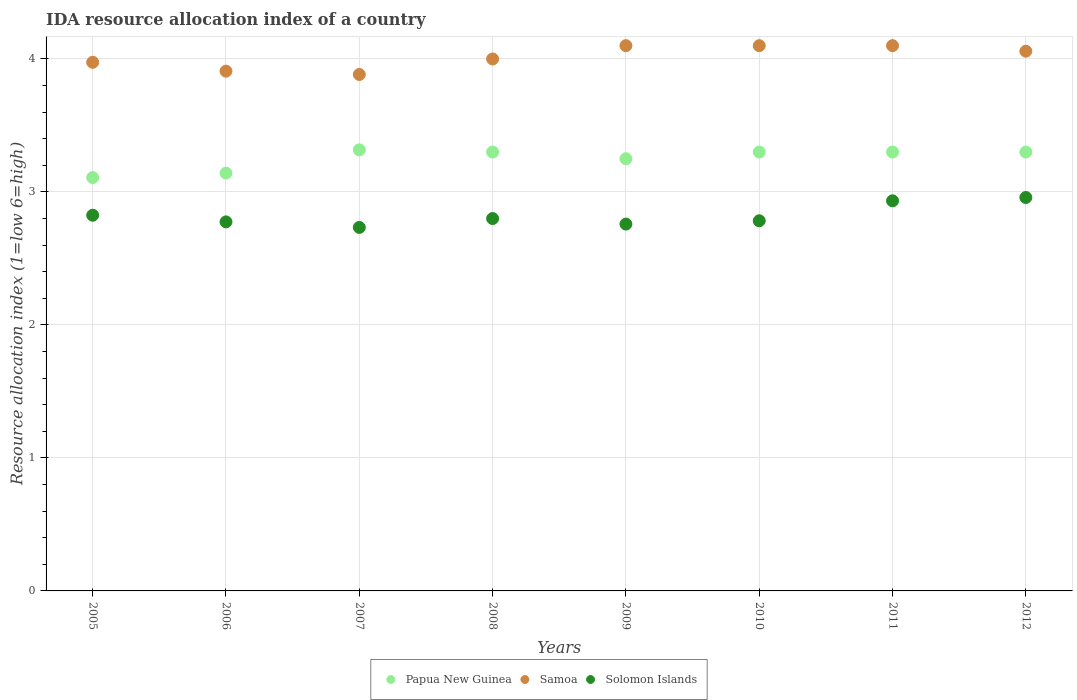How many different coloured dotlines are there?
Your response must be concise. 3. What is the IDA resource allocation index in Samoa in 2012?
Provide a succinct answer. 4.06. Across all years, what is the maximum IDA resource allocation index in Solomon Islands?
Ensure brevity in your answer.  2.96. Across all years, what is the minimum IDA resource allocation index in Samoa?
Keep it short and to the point. 3.88. In which year was the IDA resource allocation index in Papua New Guinea minimum?
Your answer should be very brief. 2005. What is the total IDA resource allocation index in Papua New Guinea in the graph?
Offer a terse response. 26.02. What is the difference between the IDA resource allocation index in Papua New Guinea in 2010 and that in 2012?
Offer a terse response. 0. What is the difference between the IDA resource allocation index in Samoa in 2010 and the IDA resource allocation index in Solomon Islands in 2009?
Make the answer very short. 1.34. What is the average IDA resource allocation index in Samoa per year?
Keep it short and to the point. 4.02. In the year 2008, what is the difference between the IDA resource allocation index in Papua New Guinea and IDA resource allocation index in Solomon Islands?
Offer a very short reply. 0.5. In how many years, is the IDA resource allocation index in Solomon Islands greater than 0.8?
Offer a very short reply. 8. What is the ratio of the IDA resource allocation index in Papua New Guinea in 2007 to that in 2010?
Your response must be concise. 1.01. Is the IDA resource allocation index in Papua New Guinea in 2006 less than that in 2011?
Make the answer very short. Yes. Is the difference between the IDA resource allocation index in Papua New Guinea in 2008 and 2011 greater than the difference between the IDA resource allocation index in Solomon Islands in 2008 and 2011?
Provide a short and direct response. Yes. What is the difference between the highest and the second highest IDA resource allocation index in Papua New Guinea?
Your answer should be compact. 0.02. What is the difference between the highest and the lowest IDA resource allocation index in Samoa?
Your answer should be very brief. 0.22. In how many years, is the IDA resource allocation index in Samoa greater than the average IDA resource allocation index in Samoa taken over all years?
Give a very brief answer. 4. How many dotlines are there?
Your answer should be compact. 3. What is the difference between two consecutive major ticks on the Y-axis?
Provide a short and direct response. 1. Are the values on the major ticks of Y-axis written in scientific E-notation?
Provide a short and direct response. No. Does the graph contain grids?
Make the answer very short. Yes. Where does the legend appear in the graph?
Keep it short and to the point. Bottom center. How are the legend labels stacked?
Provide a succinct answer. Horizontal. What is the title of the graph?
Provide a succinct answer. IDA resource allocation index of a country. Does "Greenland" appear as one of the legend labels in the graph?
Ensure brevity in your answer.  No. What is the label or title of the Y-axis?
Give a very brief answer. Resource allocation index (1=low 6=high). What is the Resource allocation index (1=low 6=high) in Papua New Guinea in 2005?
Your answer should be very brief. 3.11. What is the Resource allocation index (1=low 6=high) of Samoa in 2005?
Provide a short and direct response. 3.98. What is the Resource allocation index (1=low 6=high) in Solomon Islands in 2005?
Keep it short and to the point. 2.83. What is the Resource allocation index (1=low 6=high) of Papua New Guinea in 2006?
Make the answer very short. 3.14. What is the Resource allocation index (1=low 6=high) in Samoa in 2006?
Give a very brief answer. 3.91. What is the Resource allocation index (1=low 6=high) in Solomon Islands in 2006?
Keep it short and to the point. 2.77. What is the Resource allocation index (1=low 6=high) in Papua New Guinea in 2007?
Offer a terse response. 3.32. What is the Resource allocation index (1=low 6=high) of Samoa in 2007?
Keep it short and to the point. 3.88. What is the Resource allocation index (1=low 6=high) of Solomon Islands in 2007?
Keep it short and to the point. 2.73. What is the Resource allocation index (1=low 6=high) in Samoa in 2008?
Offer a terse response. 4. What is the Resource allocation index (1=low 6=high) in Solomon Islands in 2008?
Offer a terse response. 2.8. What is the Resource allocation index (1=low 6=high) of Papua New Guinea in 2009?
Your answer should be very brief. 3.25. What is the Resource allocation index (1=low 6=high) in Solomon Islands in 2009?
Offer a terse response. 2.76. What is the Resource allocation index (1=low 6=high) of Papua New Guinea in 2010?
Give a very brief answer. 3.3. What is the Resource allocation index (1=low 6=high) of Samoa in 2010?
Your response must be concise. 4.1. What is the Resource allocation index (1=low 6=high) of Solomon Islands in 2010?
Offer a very short reply. 2.78. What is the Resource allocation index (1=low 6=high) of Papua New Guinea in 2011?
Make the answer very short. 3.3. What is the Resource allocation index (1=low 6=high) of Solomon Islands in 2011?
Give a very brief answer. 2.93. What is the Resource allocation index (1=low 6=high) of Papua New Guinea in 2012?
Your answer should be very brief. 3.3. What is the Resource allocation index (1=low 6=high) in Samoa in 2012?
Give a very brief answer. 4.06. What is the Resource allocation index (1=low 6=high) of Solomon Islands in 2012?
Your response must be concise. 2.96. Across all years, what is the maximum Resource allocation index (1=low 6=high) in Papua New Guinea?
Your response must be concise. 3.32. Across all years, what is the maximum Resource allocation index (1=low 6=high) in Solomon Islands?
Your answer should be very brief. 2.96. Across all years, what is the minimum Resource allocation index (1=low 6=high) in Papua New Guinea?
Your answer should be very brief. 3.11. Across all years, what is the minimum Resource allocation index (1=low 6=high) of Samoa?
Provide a succinct answer. 3.88. Across all years, what is the minimum Resource allocation index (1=low 6=high) in Solomon Islands?
Ensure brevity in your answer.  2.73. What is the total Resource allocation index (1=low 6=high) in Papua New Guinea in the graph?
Provide a succinct answer. 26.02. What is the total Resource allocation index (1=low 6=high) in Samoa in the graph?
Give a very brief answer. 32.12. What is the total Resource allocation index (1=low 6=high) in Solomon Islands in the graph?
Offer a very short reply. 22.57. What is the difference between the Resource allocation index (1=low 6=high) of Papua New Guinea in 2005 and that in 2006?
Your response must be concise. -0.03. What is the difference between the Resource allocation index (1=low 6=high) of Samoa in 2005 and that in 2006?
Keep it short and to the point. 0.07. What is the difference between the Resource allocation index (1=low 6=high) in Papua New Guinea in 2005 and that in 2007?
Offer a very short reply. -0.21. What is the difference between the Resource allocation index (1=low 6=high) in Samoa in 2005 and that in 2007?
Provide a succinct answer. 0.09. What is the difference between the Resource allocation index (1=low 6=high) of Solomon Islands in 2005 and that in 2007?
Your answer should be compact. 0.09. What is the difference between the Resource allocation index (1=low 6=high) of Papua New Guinea in 2005 and that in 2008?
Offer a terse response. -0.19. What is the difference between the Resource allocation index (1=low 6=high) in Samoa in 2005 and that in 2008?
Your response must be concise. -0.03. What is the difference between the Resource allocation index (1=low 6=high) of Solomon Islands in 2005 and that in 2008?
Offer a terse response. 0.03. What is the difference between the Resource allocation index (1=low 6=high) of Papua New Guinea in 2005 and that in 2009?
Ensure brevity in your answer.  -0.14. What is the difference between the Resource allocation index (1=low 6=high) of Samoa in 2005 and that in 2009?
Your answer should be very brief. -0.12. What is the difference between the Resource allocation index (1=low 6=high) of Solomon Islands in 2005 and that in 2009?
Make the answer very short. 0.07. What is the difference between the Resource allocation index (1=low 6=high) of Papua New Guinea in 2005 and that in 2010?
Give a very brief answer. -0.19. What is the difference between the Resource allocation index (1=low 6=high) in Samoa in 2005 and that in 2010?
Your response must be concise. -0.12. What is the difference between the Resource allocation index (1=low 6=high) in Solomon Islands in 2005 and that in 2010?
Provide a succinct answer. 0.04. What is the difference between the Resource allocation index (1=low 6=high) in Papua New Guinea in 2005 and that in 2011?
Your response must be concise. -0.19. What is the difference between the Resource allocation index (1=low 6=high) of Samoa in 2005 and that in 2011?
Keep it short and to the point. -0.12. What is the difference between the Resource allocation index (1=low 6=high) of Solomon Islands in 2005 and that in 2011?
Offer a very short reply. -0.11. What is the difference between the Resource allocation index (1=low 6=high) of Papua New Guinea in 2005 and that in 2012?
Provide a short and direct response. -0.19. What is the difference between the Resource allocation index (1=low 6=high) of Samoa in 2005 and that in 2012?
Provide a short and direct response. -0.08. What is the difference between the Resource allocation index (1=low 6=high) of Solomon Islands in 2005 and that in 2012?
Provide a short and direct response. -0.13. What is the difference between the Resource allocation index (1=low 6=high) in Papua New Guinea in 2006 and that in 2007?
Give a very brief answer. -0.17. What is the difference between the Resource allocation index (1=low 6=high) of Samoa in 2006 and that in 2007?
Provide a succinct answer. 0.03. What is the difference between the Resource allocation index (1=low 6=high) in Solomon Islands in 2006 and that in 2007?
Your answer should be very brief. 0.04. What is the difference between the Resource allocation index (1=low 6=high) of Papua New Guinea in 2006 and that in 2008?
Ensure brevity in your answer.  -0.16. What is the difference between the Resource allocation index (1=low 6=high) of Samoa in 2006 and that in 2008?
Your response must be concise. -0.09. What is the difference between the Resource allocation index (1=low 6=high) in Solomon Islands in 2006 and that in 2008?
Provide a short and direct response. -0.03. What is the difference between the Resource allocation index (1=low 6=high) in Papua New Guinea in 2006 and that in 2009?
Offer a very short reply. -0.11. What is the difference between the Resource allocation index (1=low 6=high) of Samoa in 2006 and that in 2009?
Give a very brief answer. -0.19. What is the difference between the Resource allocation index (1=low 6=high) of Solomon Islands in 2006 and that in 2009?
Ensure brevity in your answer.  0.02. What is the difference between the Resource allocation index (1=low 6=high) in Papua New Guinea in 2006 and that in 2010?
Offer a very short reply. -0.16. What is the difference between the Resource allocation index (1=low 6=high) of Samoa in 2006 and that in 2010?
Offer a very short reply. -0.19. What is the difference between the Resource allocation index (1=low 6=high) of Solomon Islands in 2006 and that in 2010?
Your answer should be compact. -0.01. What is the difference between the Resource allocation index (1=low 6=high) of Papua New Guinea in 2006 and that in 2011?
Provide a succinct answer. -0.16. What is the difference between the Resource allocation index (1=low 6=high) in Samoa in 2006 and that in 2011?
Offer a terse response. -0.19. What is the difference between the Resource allocation index (1=low 6=high) in Solomon Islands in 2006 and that in 2011?
Your answer should be compact. -0.16. What is the difference between the Resource allocation index (1=low 6=high) in Papua New Guinea in 2006 and that in 2012?
Give a very brief answer. -0.16. What is the difference between the Resource allocation index (1=low 6=high) in Samoa in 2006 and that in 2012?
Ensure brevity in your answer.  -0.15. What is the difference between the Resource allocation index (1=low 6=high) in Solomon Islands in 2006 and that in 2012?
Keep it short and to the point. -0.18. What is the difference between the Resource allocation index (1=low 6=high) in Papua New Guinea in 2007 and that in 2008?
Make the answer very short. 0.02. What is the difference between the Resource allocation index (1=low 6=high) in Samoa in 2007 and that in 2008?
Your response must be concise. -0.12. What is the difference between the Resource allocation index (1=low 6=high) in Solomon Islands in 2007 and that in 2008?
Make the answer very short. -0.07. What is the difference between the Resource allocation index (1=low 6=high) of Papua New Guinea in 2007 and that in 2009?
Your answer should be very brief. 0.07. What is the difference between the Resource allocation index (1=low 6=high) of Samoa in 2007 and that in 2009?
Offer a very short reply. -0.22. What is the difference between the Resource allocation index (1=low 6=high) in Solomon Islands in 2007 and that in 2009?
Offer a very short reply. -0.03. What is the difference between the Resource allocation index (1=low 6=high) of Papua New Guinea in 2007 and that in 2010?
Your response must be concise. 0.02. What is the difference between the Resource allocation index (1=low 6=high) in Samoa in 2007 and that in 2010?
Provide a short and direct response. -0.22. What is the difference between the Resource allocation index (1=low 6=high) of Solomon Islands in 2007 and that in 2010?
Your answer should be very brief. -0.05. What is the difference between the Resource allocation index (1=low 6=high) in Papua New Guinea in 2007 and that in 2011?
Offer a terse response. 0.02. What is the difference between the Resource allocation index (1=low 6=high) in Samoa in 2007 and that in 2011?
Give a very brief answer. -0.22. What is the difference between the Resource allocation index (1=low 6=high) of Papua New Guinea in 2007 and that in 2012?
Give a very brief answer. 0.02. What is the difference between the Resource allocation index (1=low 6=high) in Samoa in 2007 and that in 2012?
Keep it short and to the point. -0.17. What is the difference between the Resource allocation index (1=low 6=high) of Solomon Islands in 2007 and that in 2012?
Keep it short and to the point. -0.23. What is the difference between the Resource allocation index (1=low 6=high) in Solomon Islands in 2008 and that in 2009?
Your response must be concise. 0.04. What is the difference between the Resource allocation index (1=low 6=high) of Samoa in 2008 and that in 2010?
Your answer should be compact. -0.1. What is the difference between the Resource allocation index (1=low 6=high) in Solomon Islands in 2008 and that in 2010?
Offer a terse response. 0.02. What is the difference between the Resource allocation index (1=low 6=high) in Papua New Guinea in 2008 and that in 2011?
Provide a short and direct response. 0. What is the difference between the Resource allocation index (1=low 6=high) of Solomon Islands in 2008 and that in 2011?
Give a very brief answer. -0.13. What is the difference between the Resource allocation index (1=low 6=high) in Papua New Guinea in 2008 and that in 2012?
Make the answer very short. 0. What is the difference between the Resource allocation index (1=low 6=high) in Samoa in 2008 and that in 2012?
Provide a short and direct response. -0.06. What is the difference between the Resource allocation index (1=low 6=high) of Solomon Islands in 2008 and that in 2012?
Provide a succinct answer. -0.16. What is the difference between the Resource allocation index (1=low 6=high) of Papua New Guinea in 2009 and that in 2010?
Provide a succinct answer. -0.05. What is the difference between the Resource allocation index (1=low 6=high) of Samoa in 2009 and that in 2010?
Keep it short and to the point. 0. What is the difference between the Resource allocation index (1=low 6=high) of Solomon Islands in 2009 and that in 2010?
Your answer should be compact. -0.03. What is the difference between the Resource allocation index (1=low 6=high) in Papua New Guinea in 2009 and that in 2011?
Keep it short and to the point. -0.05. What is the difference between the Resource allocation index (1=low 6=high) in Samoa in 2009 and that in 2011?
Keep it short and to the point. 0. What is the difference between the Resource allocation index (1=low 6=high) in Solomon Islands in 2009 and that in 2011?
Your answer should be compact. -0.17. What is the difference between the Resource allocation index (1=low 6=high) of Samoa in 2009 and that in 2012?
Provide a succinct answer. 0.04. What is the difference between the Resource allocation index (1=low 6=high) of Papua New Guinea in 2010 and that in 2011?
Your answer should be compact. 0. What is the difference between the Resource allocation index (1=low 6=high) of Samoa in 2010 and that in 2011?
Your response must be concise. 0. What is the difference between the Resource allocation index (1=low 6=high) in Samoa in 2010 and that in 2012?
Give a very brief answer. 0.04. What is the difference between the Resource allocation index (1=low 6=high) of Solomon Islands in 2010 and that in 2012?
Ensure brevity in your answer.  -0.17. What is the difference between the Resource allocation index (1=low 6=high) of Samoa in 2011 and that in 2012?
Your response must be concise. 0.04. What is the difference between the Resource allocation index (1=low 6=high) of Solomon Islands in 2011 and that in 2012?
Your answer should be compact. -0.03. What is the difference between the Resource allocation index (1=low 6=high) in Papua New Guinea in 2005 and the Resource allocation index (1=low 6=high) in Samoa in 2007?
Your answer should be compact. -0.78. What is the difference between the Resource allocation index (1=low 6=high) of Papua New Guinea in 2005 and the Resource allocation index (1=low 6=high) of Solomon Islands in 2007?
Offer a very short reply. 0.38. What is the difference between the Resource allocation index (1=low 6=high) of Samoa in 2005 and the Resource allocation index (1=low 6=high) of Solomon Islands in 2007?
Keep it short and to the point. 1.24. What is the difference between the Resource allocation index (1=low 6=high) of Papua New Guinea in 2005 and the Resource allocation index (1=low 6=high) of Samoa in 2008?
Your response must be concise. -0.89. What is the difference between the Resource allocation index (1=low 6=high) of Papua New Guinea in 2005 and the Resource allocation index (1=low 6=high) of Solomon Islands in 2008?
Provide a succinct answer. 0.31. What is the difference between the Resource allocation index (1=low 6=high) of Samoa in 2005 and the Resource allocation index (1=low 6=high) of Solomon Islands in 2008?
Give a very brief answer. 1.18. What is the difference between the Resource allocation index (1=low 6=high) of Papua New Guinea in 2005 and the Resource allocation index (1=low 6=high) of Samoa in 2009?
Make the answer very short. -0.99. What is the difference between the Resource allocation index (1=low 6=high) in Papua New Guinea in 2005 and the Resource allocation index (1=low 6=high) in Solomon Islands in 2009?
Keep it short and to the point. 0.35. What is the difference between the Resource allocation index (1=low 6=high) of Samoa in 2005 and the Resource allocation index (1=low 6=high) of Solomon Islands in 2009?
Keep it short and to the point. 1.22. What is the difference between the Resource allocation index (1=low 6=high) of Papua New Guinea in 2005 and the Resource allocation index (1=low 6=high) of Samoa in 2010?
Make the answer very short. -0.99. What is the difference between the Resource allocation index (1=low 6=high) of Papua New Guinea in 2005 and the Resource allocation index (1=low 6=high) of Solomon Islands in 2010?
Provide a succinct answer. 0.33. What is the difference between the Resource allocation index (1=low 6=high) in Samoa in 2005 and the Resource allocation index (1=low 6=high) in Solomon Islands in 2010?
Offer a very short reply. 1.19. What is the difference between the Resource allocation index (1=low 6=high) of Papua New Guinea in 2005 and the Resource allocation index (1=low 6=high) of Samoa in 2011?
Make the answer very short. -0.99. What is the difference between the Resource allocation index (1=low 6=high) of Papua New Guinea in 2005 and the Resource allocation index (1=low 6=high) of Solomon Islands in 2011?
Offer a terse response. 0.17. What is the difference between the Resource allocation index (1=low 6=high) in Samoa in 2005 and the Resource allocation index (1=low 6=high) in Solomon Islands in 2011?
Give a very brief answer. 1.04. What is the difference between the Resource allocation index (1=low 6=high) in Papua New Guinea in 2005 and the Resource allocation index (1=low 6=high) in Samoa in 2012?
Your response must be concise. -0.95. What is the difference between the Resource allocation index (1=low 6=high) in Samoa in 2005 and the Resource allocation index (1=low 6=high) in Solomon Islands in 2012?
Give a very brief answer. 1.02. What is the difference between the Resource allocation index (1=low 6=high) in Papua New Guinea in 2006 and the Resource allocation index (1=low 6=high) in Samoa in 2007?
Offer a terse response. -0.74. What is the difference between the Resource allocation index (1=low 6=high) of Papua New Guinea in 2006 and the Resource allocation index (1=low 6=high) of Solomon Islands in 2007?
Offer a terse response. 0.41. What is the difference between the Resource allocation index (1=low 6=high) of Samoa in 2006 and the Resource allocation index (1=low 6=high) of Solomon Islands in 2007?
Your answer should be very brief. 1.18. What is the difference between the Resource allocation index (1=low 6=high) in Papua New Guinea in 2006 and the Resource allocation index (1=low 6=high) in Samoa in 2008?
Make the answer very short. -0.86. What is the difference between the Resource allocation index (1=low 6=high) in Papua New Guinea in 2006 and the Resource allocation index (1=low 6=high) in Solomon Islands in 2008?
Your response must be concise. 0.34. What is the difference between the Resource allocation index (1=low 6=high) in Samoa in 2006 and the Resource allocation index (1=low 6=high) in Solomon Islands in 2008?
Your answer should be very brief. 1.11. What is the difference between the Resource allocation index (1=low 6=high) of Papua New Guinea in 2006 and the Resource allocation index (1=low 6=high) of Samoa in 2009?
Ensure brevity in your answer.  -0.96. What is the difference between the Resource allocation index (1=low 6=high) of Papua New Guinea in 2006 and the Resource allocation index (1=low 6=high) of Solomon Islands in 2009?
Give a very brief answer. 0.38. What is the difference between the Resource allocation index (1=low 6=high) in Samoa in 2006 and the Resource allocation index (1=low 6=high) in Solomon Islands in 2009?
Ensure brevity in your answer.  1.15. What is the difference between the Resource allocation index (1=low 6=high) of Papua New Guinea in 2006 and the Resource allocation index (1=low 6=high) of Samoa in 2010?
Your answer should be compact. -0.96. What is the difference between the Resource allocation index (1=low 6=high) in Papua New Guinea in 2006 and the Resource allocation index (1=low 6=high) in Solomon Islands in 2010?
Ensure brevity in your answer.  0.36. What is the difference between the Resource allocation index (1=low 6=high) in Samoa in 2006 and the Resource allocation index (1=low 6=high) in Solomon Islands in 2010?
Your answer should be very brief. 1.12. What is the difference between the Resource allocation index (1=low 6=high) in Papua New Guinea in 2006 and the Resource allocation index (1=low 6=high) in Samoa in 2011?
Make the answer very short. -0.96. What is the difference between the Resource allocation index (1=low 6=high) in Papua New Guinea in 2006 and the Resource allocation index (1=low 6=high) in Solomon Islands in 2011?
Offer a terse response. 0.21. What is the difference between the Resource allocation index (1=low 6=high) of Papua New Guinea in 2006 and the Resource allocation index (1=low 6=high) of Samoa in 2012?
Your response must be concise. -0.92. What is the difference between the Resource allocation index (1=low 6=high) in Papua New Guinea in 2006 and the Resource allocation index (1=low 6=high) in Solomon Islands in 2012?
Make the answer very short. 0.18. What is the difference between the Resource allocation index (1=low 6=high) in Papua New Guinea in 2007 and the Resource allocation index (1=low 6=high) in Samoa in 2008?
Offer a very short reply. -0.68. What is the difference between the Resource allocation index (1=low 6=high) in Papua New Guinea in 2007 and the Resource allocation index (1=low 6=high) in Solomon Islands in 2008?
Provide a short and direct response. 0.52. What is the difference between the Resource allocation index (1=low 6=high) of Papua New Guinea in 2007 and the Resource allocation index (1=low 6=high) of Samoa in 2009?
Offer a terse response. -0.78. What is the difference between the Resource allocation index (1=low 6=high) of Papua New Guinea in 2007 and the Resource allocation index (1=low 6=high) of Solomon Islands in 2009?
Provide a short and direct response. 0.56. What is the difference between the Resource allocation index (1=low 6=high) in Samoa in 2007 and the Resource allocation index (1=low 6=high) in Solomon Islands in 2009?
Your answer should be compact. 1.12. What is the difference between the Resource allocation index (1=low 6=high) of Papua New Guinea in 2007 and the Resource allocation index (1=low 6=high) of Samoa in 2010?
Make the answer very short. -0.78. What is the difference between the Resource allocation index (1=low 6=high) of Papua New Guinea in 2007 and the Resource allocation index (1=low 6=high) of Solomon Islands in 2010?
Provide a succinct answer. 0.53. What is the difference between the Resource allocation index (1=low 6=high) in Papua New Guinea in 2007 and the Resource allocation index (1=low 6=high) in Samoa in 2011?
Provide a short and direct response. -0.78. What is the difference between the Resource allocation index (1=low 6=high) in Papua New Guinea in 2007 and the Resource allocation index (1=low 6=high) in Solomon Islands in 2011?
Ensure brevity in your answer.  0.38. What is the difference between the Resource allocation index (1=low 6=high) of Papua New Guinea in 2007 and the Resource allocation index (1=low 6=high) of Samoa in 2012?
Your answer should be very brief. -0.74. What is the difference between the Resource allocation index (1=low 6=high) of Papua New Guinea in 2007 and the Resource allocation index (1=low 6=high) of Solomon Islands in 2012?
Make the answer very short. 0.36. What is the difference between the Resource allocation index (1=low 6=high) of Samoa in 2007 and the Resource allocation index (1=low 6=high) of Solomon Islands in 2012?
Your answer should be compact. 0.93. What is the difference between the Resource allocation index (1=low 6=high) in Papua New Guinea in 2008 and the Resource allocation index (1=low 6=high) in Solomon Islands in 2009?
Provide a succinct answer. 0.54. What is the difference between the Resource allocation index (1=low 6=high) in Samoa in 2008 and the Resource allocation index (1=low 6=high) in Solomon Islands in 2009?
Your answer should be compact. 1.24. What is the difference between the Resource allocation index (1=low 6=high) of Papua New Guinea in 2008 and the Resource allocation index (1=low 6=high) of Solomon Islands in 2010?
Offer a very short reply. 0.52. What is the difference between the Resource allocation index (1=low 6=high) of Samoa in 2008 and the Resource allocation index (1=low 6=high) of Solomon Islands in 2010?
Ensure brevity in your answer.  1.22. What is the difference between the Resource allocation index (1=low 6=high) of Papua New Guinea in 2008 and the Resource allocation index (1=low 6=high) of Samoa in 2011?
Provide a succinct answer. -0.8. What is the difference between the Resource allocation index (1=low 6=high) of Papua New Guinea in 2008 and the Resource allocation index (1=low 6=high) of Solomon Islands in 2011?
Give a very brief answer. 0.37. What is the difference between the Resource allocation index (1=low 6=high) of Samoa in 2008 and the Resource allocation index (1=low 6=high) of Solomon Islands in 2011?
Keep it short and to the point. 1.07. What is the difference between the Resource allocation index (1=low 6=high) of Papua New Guinea in 2008 and the Resource allocation index (1=low 6=high) of Samoa in 2012?
Ensure brevity in your answer.  -0.76. What is the difference between the Resource allocation index (1=low 6=high) of Papua New Guinea in 2008 and the Resource allocation index (1=low 6=high) of Solomon Islands in 2012?
Give a very brief answer. 0.34. What is the difference between the Resource allocation index (1=low 6=high) of Samoa in 2008 and the Resource allocation index (1=low 6=high) of Solomon Islands in 2012?
Offer a very short reply. 1.04. What is the difference between the Resource allocation index (1=low 6=high) of Papua New Guinea in 2009 and the Resource allocation index (1=low 6=high) of Samoa in 2010?
Provide a short and direct response. -0.85. What is the difference between the Resource allocation index (1=low 6=high) in Papua New Guinea in 2009 and the Resource allocation index (1=low 6=high) in Solomon Islands in 2010?
Ensure brevity in your answer.  0.47. What is the difference between the Resource allocation index (1=low 6=high) of Samoa in 2009 and the Resource allocation index (1=low 6=high) of Solomon Islands in 2010?
Offer a very short reply. 1.32. What is the difference between the Resource allocation index (1=low 6=high) of Papua New Guinea in 2009 and the Resource allocation index (1=low 6=high) of Samoa in 2011?
Your answer should be very brief. -0.85. What is the difference between the Resource allocation index (1=low 6=high) in Papua New Guinea in 2009 and the Resource allocation index (1=low 6=high) in Solomon Islands in 2011?
Give a very brief answer. 0.32. What is the difference between the Resource allocation index (1=low 6=high) of Papua New Guinea in 2009 and the Resource allocation index (1=low 6=high) of Samoa in 2012?
Keep it short and to the point. -0.81. What is the difference between the Resource allocation index (1=low 6=high) in Papua New Guinea in 2009 and the Resource allocation index (1=low 6=high) in Solomon Islands in 2012?
Your response must be concise. 0.29. What is the difference between the Resource allocation index (1=low 6=high) in Samoa in 2009 and the Resource allocation index (1=low 6=high) in Solomon Islands in 2012?
Ensure brevity in your answer.  1.14. What is the difference between the Resource allocation index (1=low 6=high) of Papua New Guinea in 2010 and the Resource allocation index (1=low 6=high) of Solomon Islands in 2011?
Make the answer very short. 0.37. What is the difference between the Resource allocation index (1=low 6=high) of Papua New Guinea in 2010 and the Resource allocation index (1=low 6=high) of Samoa in 2012?
Provide a short and direct response. -0.76. What is the difference between the Resource allocation index (1=low 6=high) in Papua New Guinea in 2010 and the Resource allocation index (1=low 6=high) in Solomon Islands in 2012?
Give a very brief answer. 0.34. What is the difference between the Resource allocation index (1=low 6=high) in Samoa in 2010 and the Resource allocation index (1=low 6=high) in Solomon Islands in 2012?
Your answer should be compact. 1.14. What is the difference between the Resource allocation index (1=low 6=high) of Papua New Guinea in 2011 and the Resource allocation index (1=low 6=high) of Samoa in 2012?
Offer a very short reply. -0.76. What is the difference between the Resource allocation index (1=low 6=high) of Papua New Guinea in 2011 and the Resource allocation index (1=low 6=high) of Solomon Islands in 2012?
Give a very brief answer. 0.34. What is the difference between the Resource allocation index (1=low 6=high) of Samoa in 2011 and the Resource allocation index (1=low 6=high) of Solomon Islands in 2012?
Your answer should be compact. 1.14. What is the average Resource allocation index (1=low 6=high) of Papua New Guinea per year?
Provide a succinct answer. 3.25. What is the average Resource allocation index (1=low 6=high) in Samoa per year?
Keep it short and to the point. 4.02. What is the average Resource allocation index (1=low 6=high) of Solomon Islands per year?
Keep it short and to the point. 2.82. In the year 2005, what is the difference between the Resource allocation index (1=low 6=high) in Papua New Guinea and Resource allocation index (1=low 6=high) in Samoa?
Give a very brief answer. -0.87. In the year 2005, what is the difference between the Resource allocation index (1=low 6=high) in Papua New Guinea and Resource allocation index (1=low 6=high) in Solomon Islands?
Give a very brief answer. 0.28. In the year 2005, what is the difference between the Resource allocation index (1=low 6=high) in Samoa and Resource allocation index (1=low 6=high) in Solomon Islands?
Your response must be concise. 1.15. In the year 2006, what is the difference between the Resource allocation index (1=low 6=high) in Papua New Guinea and Resource allocation index (1=low 6=high) in Samoa?
Provide a short and direct response. -0.77. In the year 2006, what is the difference between the Resource allocation index (1=low 6=high) of Papua New Guinea and Resource allocation index (1=low 6=high) of Solomon Islands?
Offer a very short reply. 0.37. In the year 2006, what is the difference between the Resource allocation index (1=low 6=high) of Samoa and Resource allocation index (1=low 6=high) of Solomon Islands?
Offer a very short reply. 1.13. In the year 2007, what is the difference between the Resource allocation index (1=low 6=high) in Papua New Guinea and Resource allocation index (1=low 6=high) in Samoa?
Give a very brief answer. -0.57. In the year 2007, what is the difference between the Resource allocation index (1=low 6=high) in Papua New Guinea and Resource allocation index (1=low 6=high) in Solomon Islands?
Provide a short and direct response. 0.58. In the year 2007, what is the difference between the Resource allocation index (1=low 6=high) of Samoa and Resource allocation index (1=low 6=high) of Solomon Islands?
Your response must be concise. 1.15. In the year 2008, what is the difference between the Resource allocation index (1=low 6=high) of Papua New Guinea and Resource allocation index (1=low 6=high) of Solomon Islands?
Ensure brevity in your answer.  0.5. In the year 2009, what is the difference between the Resource allocation index (1=low 6=high) in Papua New Guinea and Resource allocation index (1=low 6=high) in Samoa?
Give a very brief answer. -0.85. In the year 2009, what is the difference between the Resource allocation index (1=low 6=high) of Papua New Guinea and Resource allocation index (1=low 6=high) of Solomon Islands?
Offer a very short reply. 0.49. In the year 2009, what is the difference between the Resource allocation index (1=low 6=high) of Samoa and Resource allocation index (1=low 6=high) of Solomon Islands?
Your response must be concise. 1.34. In the year 2010, what is the difference between the Resource allocation index (1=low 6=high) of Papua New Guinea and Resource allocation index (1=low 6=high) of Samoa?
Provide a short and direct response. -0.8. In the year 2010, what is the difference between the Resource allocation index (1=low 6=high) in Papua New Guinea and Resource allocation index (1=low 6=high) in Solomon Islands?
Keep it short and to the point. 0.52. In the year 2010, what is the difference between the Resource allocation index (1=low 6=high) in Samoa and Resource allocation index (1=low 6=high) in Solomon Islands?
Offer a terse response. 1.32. In the year 2011, what is the difference between the Resource allocation index (1=low 6=high) of Papua New Guinea and Resource allocation index (1=low 6=high) of Solomon Islands?
Your answer should be compact. 0.37. In the year 2012, what is the difference between the Resource allocation index (1=low 6=high) of Papua New Guinea and Resource allocation index (1=low 6=high) of Samoa?
Your answer should be very brief. -0.76. In the year 2012, what is the difference between the Resource allocation index (1=low 6=high) of Papua New Guinea and Resource allocation index (1=low 6=high) of Solomon Islands?
Your answer should be compact. 0.34. In the year 2012, what is the difference between the Resource allocation index (1=low 6=high) in Samoa and Resource allocation index (1=low 6=high) in Solomon Islands?
Offer a terse response. 1.1. What is the ratio of the Resource allocation index (1=low 6=high) of Samoa in 2005 to that in 2006?
Provide a short and direct response. 1.02. What is the ratio of the Resource allocation index (1=low 6=high) in Solomon Islands in 2005 to that in 2006?
Offer a terse response. 1.02. What is the ratio of the Resource allocation index (1=low 6=high) in Papua New Guinea in 2005 to that in 2007?
Ensure brevity in your answer.  0.94. What is the ratio of the Resource allocation index (1=low 6=high) in Samoa in 2005 to that in 2007?
Offer a very short reply. 1.02. What is the ratio of the Resource allocation index (1=low 6=high) in Solomon Islands in 2005 to that in 2007?
Give a very brief answer. 1.03. What is the ratio of the Resource allocation index (1=low 6=high) of Papua New Guinea in 2005 to that in 2008?
Give a very brief answer. 0.94. What is the ratio of the Resource allocation index (1=low 6=high) in Samoa in 2005 to that in 2008?
Provide a short and direct response. 0.99. What is the ratio of the Resource allocation index (1=low 6=high) in Solomon Islands in 2005 to that in 2008?
Provide a short and direct response. 1.01. What is the ratio of the Resource allocation index (1=low 6=high) of Papua New Guinea in 2005 to that in 2009?
Ensure brevity in your answer.  0.96. What is the ratio of the Resource allocation index (1=low 6=high) of Samoa in 2005 to that in 2009?
Give a very brief answer. 0.97. What is the ratio of the Resource allocation index (1=low 6=high) of Solomon Islands in 2005 to that in 2009?
Your answer should be very brief. 1.02. What is the ratio of the Resource allocation index (1=low 6=high) in Papua New Guinea in 2005 to that in 2010?
Provide a short and direct response. 0.94. What is the ratio of the Resource allocation index (1=low 6=high) in Samoa in 2005 to that in 2010?
Your answer should be very brief. 0.97. What is the ratio of the Resource allocation index (1=low 6=high) in Papua New Guinea in 2005 to that in 2011?
Your response must be concise. 0.94. What is the ratio of the Resource allocation index (1=low 6=high) in Samoa in 2005 to that in 2011?
Ensure brevity in your answer.  0.97. What is the ratio of the Resource allocation index (1=low 6=high) of Solomon Islands in 2005 to that in 2011?
Your response must be concise. 0.96. What is the ratio of the Resource allocation index (1=low 6=high) in Papua New Guinea in 2005 to that in 2012?
Your answer should be very brief. 0.94. What is the ratio of the Resource allocation index (1=low 6=high) in Samoa in 2005 to that in 2012?
Your answer should be compact. 0.98. What is the ratio of the Resource allocation index (1=low 6=high) in Solomon Islands in 2005 to that in 2012?
Your response must be concise. 0.95. What is the ratio of the Resource allocation index (1=low 6=high) in Papua New Guinea in 2006 to that in 2007?
Your answer should be compact. 0.95. What is the ratio of the Resource allocation index (1=low 6=high) of Samoa in 2006 to that in 2007?
Provide a succinct answer. 1.01. What is the ratio of the Resource allocation index (1=low 6=high) of Solomon Islands in 2006 to that in 2007?
Provide a succinct answer. 1.02. What is the ratio of the Resource allocation index (1=low 6=high) in Papua New Guinea in 2006 to that in 2008?
Provide a succinct answer. 0.95. What is the ratio of the Resource allocation index (1=low 6=high) in Samoa in 2006 to that in 2008?
Provide a short and direct response. 0.98. What is the ratio of the Resource allocation index (1=low 6=high) in Solomon Islands in 2006 to that in 2008?
Make the answer very short. 0.99. What is the ratio of the Resource allocation index (1=low 6=high) in Papua New Guinea in 2006 to that in 2009?
Keep it short and to the point. 0.97. What is the ratio of the Resource allocation index (1=low 6=high) in Samoa in 2006 to that in 2009?
Give a very brief answer. 0.95. What is the ratio of the Resource allocation index (1=low 6=high) of Samoa in 2006 to that in 2010?
Offer a terse response. 0.95. What is the ratio of the Resource allocation index (1=low 6=high) in Papua New Guinea in 2006 to that in 2011?
Your response must be concise. 0.95. What is the ratio of the Resource allocation index (1=low 6=high) of Samoa in 2006 to that in 2011?
Provide a succinct answer. 0.95. What is the ratio of the Resource allocation index (1=low 6=high) in Solomon Islands in 2006 to that in 2011?
Keep it short and to the point. 0.95. What is the ratio of the Resource allocation index (1=low 6=high) in Solomon Islands in 2006 to that in 2012?
Your response must be concise. 0.94. What is the ratio of the Resource allocation index (1=low 6=high) in Samoa in 2007 to that in 2008?
Your response must be concise. 0.97. What is the ratio of the Resource allocation index (1=low 6=high) of Solomon Islands in 2007 to that in 2008?
Provide a succinct answer. 0.98. What is the ratio of the Resource allocation index (1=low 6=high) in Papua New Guinea in 2007 to that in 2009?
Keep it short and to the point. 1.02. What is the ratio of the Resource allocation index (1=low 6=high) of Samoa in 2007 to that in 2009?
Your response must be concise. 0.95. What is the ratio of the Resource allocation index (1=low 6=high) of Solomon Islands in 2007 to that in 2009?
Your answer should be very brief. 0.99. What is the ratio of the Resource allocation index (1=low 6=high) of Samoa in 2007 to that in 2010?
Your answer should be very brief. 0.95. What is the ratio of the Resource allocation index (1=low 6=high) in Samoa in 2007 to that in 2011?
Ensure brevity in your answer.  0.95. What is the ratio of the Resource allocation index (1=low 6=high) in Solomon Islands in 2007 to that in 2011?
Offer a terse response. 0.93. What is the ratio of the Resource allocation index (1=low 6=high) in Samoa in 2007 to that in 2012?
Offer a terse response. 0.96. What is the ratio of the Resource allocation index (1=low 6=high) of Solomon Islands in 2007 to that in 2012?
Your response must be concise. 0.92. What is the ratio of the Resource allocation index (1=low 6=high) of Papua New Guinea in 2008 to that in 2009?
Ensure brevity in your answer.  1.02. What is the ratio of the Resource allocation index (1=low 6=high) in Samoa in 2008 to that in 2009?
Your answer should be very brief. 0.98. What is the ratio of the Resource allocation index (1=low 6=high) in Solomon Islands in 2008 to that in 2009?
Provide a short and direct response. 1.02. What is the ratio of the Resource allocation index (1=low 6=high) in Papua New Guinea in 2008 to that in 2010?
Offer a very short reply. 1. What is the ratio of the Resource allocation index (1=low 6=high) of Samoa in 2008 to that in 2010?
Your response must be concise. 0.98. What is the ratio of the Resource allocation index (1=low 6=high) of Papua New Guinea in 2008 to that in 2011?
Provide a succinct answer. 1. What is the ratio of the Resource allocation index (1=low 6=high) of Samoa in 2008 to that in 2011?
Ensure brevity in your answer.  0.98. What is the ratio of the Resource allocation index (1=low 6=high) of Solomon Islands in 2008 to that in 2011?
Give a very brief answer. 0.95. What is the ratio of the Resource allocation index (1=low 6=high) in Samoa in 2008 to that in 2012?
Make the answer very short. 0.99. What is the ratio of the Resource allocation index (1=low 6=high) of Solomon Islands in 2008 to that in 2012?
Provide a succinct answer. 0.95. What is the ratio of the Resource allocation index (1=low 6=high) in Papua New Guinea in 2009 to that in 2010?
Offer a very short reply. 0.98. What is the ratio of the Resource allocation index (1=low 6=high) of Papua New Guinea in 2009 to that in 2011?
Your answer should be very brief. 0.98. What is the ratio of the Resource allocation index (1=low 6=high) of Solomon Islands in 2009 to that in 2011?
Give a very brief answer. 0.94. What is the ratio of the Resource allocation index (1=low 6=high) in Samoa in 2009 to that in 2012?
Provide a short and direct response. 1.01. What is the ratio of the Resource allocation index (1=low 6=high) of Solomon Islands in 2009 to that in 2012?
Provide a short and direct response. 0.93. What is the ratio of the Resource allocation index (1=low 6=high) in Solomon Islands in 2010 to that in 2011?
Your response must be concise. 0.95. What is the ratio of the Resource allocation index (1=low 6=high) in Papua New Guinea in 2010 to that in 2012?
Your answer should be very brief. 1. What is the ratio of the Resource allocation index (1=low 6=high) in Samoa in 2010 to that in 2012?
Your response must be concise. 1.01. What is the ratio of the Resource allocation index (1=low 6=high) of Solomon Islands in 2010 to that in 2012?
Offer a very short reply. 0.94. What is the ratio of the Resource allocation index (1=low 6=high) in Papua New Guinea in 2011 to that in 2012?
Provide a short and direct response. 1. What is the ratio of the Resource allocation index (1=low 6=high) of Samoa in 2011 to that in 2012?
Keep it short and to the point. 1.01. What is the ratio of the Resource allocation index (1=low 6=high) in Solomon Islands in 2011 to that in 2012?
Your answer should be very brief. 0.99. What is the difference between the highest and the second highest Resource allocation index (1=low 6=high) in Papua New Guinea?
Provide a succinct answer. 0.02. What is the difference between the highest and the second highest Resource allocation index (1=low 6=high) of Samoa?
Keep it short and to the point. 0. What is the difference between the highest and the second highest Resource allocation index (1=low 6=high) of Solomon Islands?
Ensure brevity in your answer.  0.03. What is the difference between the highest and the lowest Resource allocation index (1=low 6=high) of Papua New Guinea?
Your answer should be compact. 0.21. What is the difference between the highest and the lowest Resource allocation index (1=low 6=high) in Samoa?
Your answer should be very brief. 0.22. What is the difference between the highest and the lowest Resource allocation index (1=low 6=high) of Solomon Islands?
Offer a terse response. 0.23. 